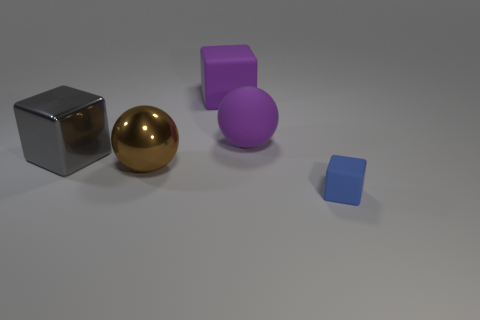Add 2 gray metal cubes. How many objects exist? 7 Subtract all blocks. How many objects are left? 2 Subtract all purple rubber objects. Subtract all blue objects. How many objects are left? 2 Add 5 metal blocks. How many metal blocks are left? 6 Add 5 small red cylinders. How many small red cylinders exist? 5 Subtract 0 red blocks. How many objects are left? 5 